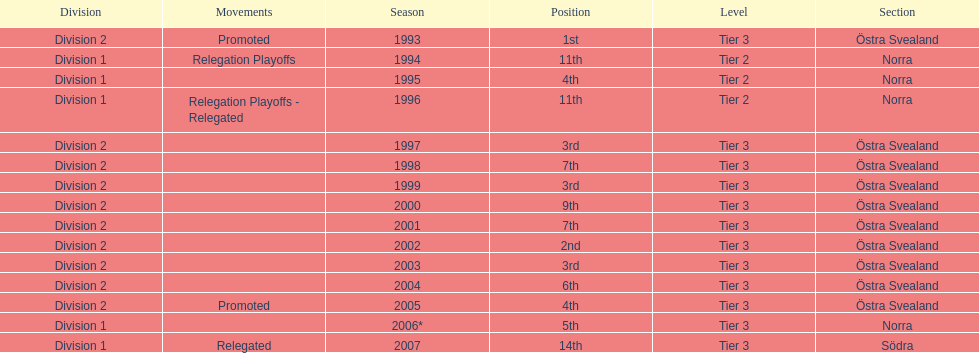What year is at least on the list? 2007. 